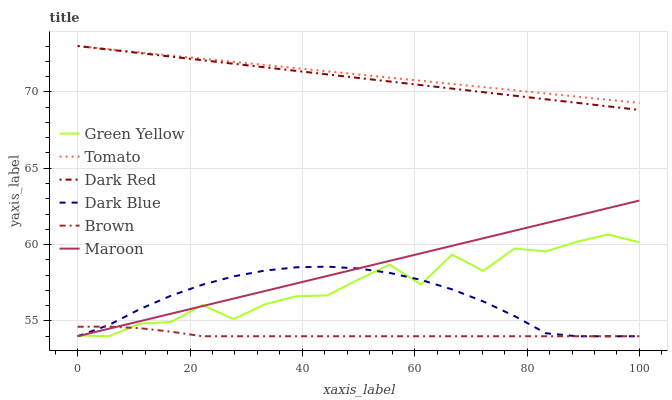Does Brown have the minimum area under the curve?
Answer yes or no. Yes. Does Tomato have the maximum area under the curve?
Answer yes or no. Yes. Does Dark Red have the minimum area under the curve?
Answer yes or no. No. Does Dark Red have the maximum area under the curve?
Answer yes or no. No. Is Dark Red the smoothest?
Answer yes or no. Yes. Is Green Yellow the roughest?
Answer yes or no. Yes. Is Brown the smoothest?
Answer yes or no. No. Is Brown the roughest?
Answer yes or no. No. Does Brown have the lowest value?
Answer yes or no. Yes. Does Dark Red have the lowest value?
Answer yes or no. No. Does Dark Red have the highest value?
Answer yes or no. Yes. Does Brown have the highest value?
Answer yes or no. No. Is Brown less than Dark Red?
Answer yes or no. Yes. Is Dark Red greater than Dark Blue?
Answer yes or no. Yes. Does Maroon intersect Green Yellow?
Answer yes or no. Yes. Is Maroon less than Green Yellow?
Answer yes or no. No. Is Maroon greater than Green Yellow?
Answer yes or no. No. Does Brown intersect Dark Red?
Answer yes or no. No. 